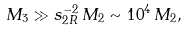<formula> <loc_0><loc_0><loc_500><loc_500>M _ { 3 } \gg s _ { 2 R } ^ { - 2 } \, M _ { 2 } \sim 1 0 ^ { 4 } \, M _ { 2 } ,</formula> 